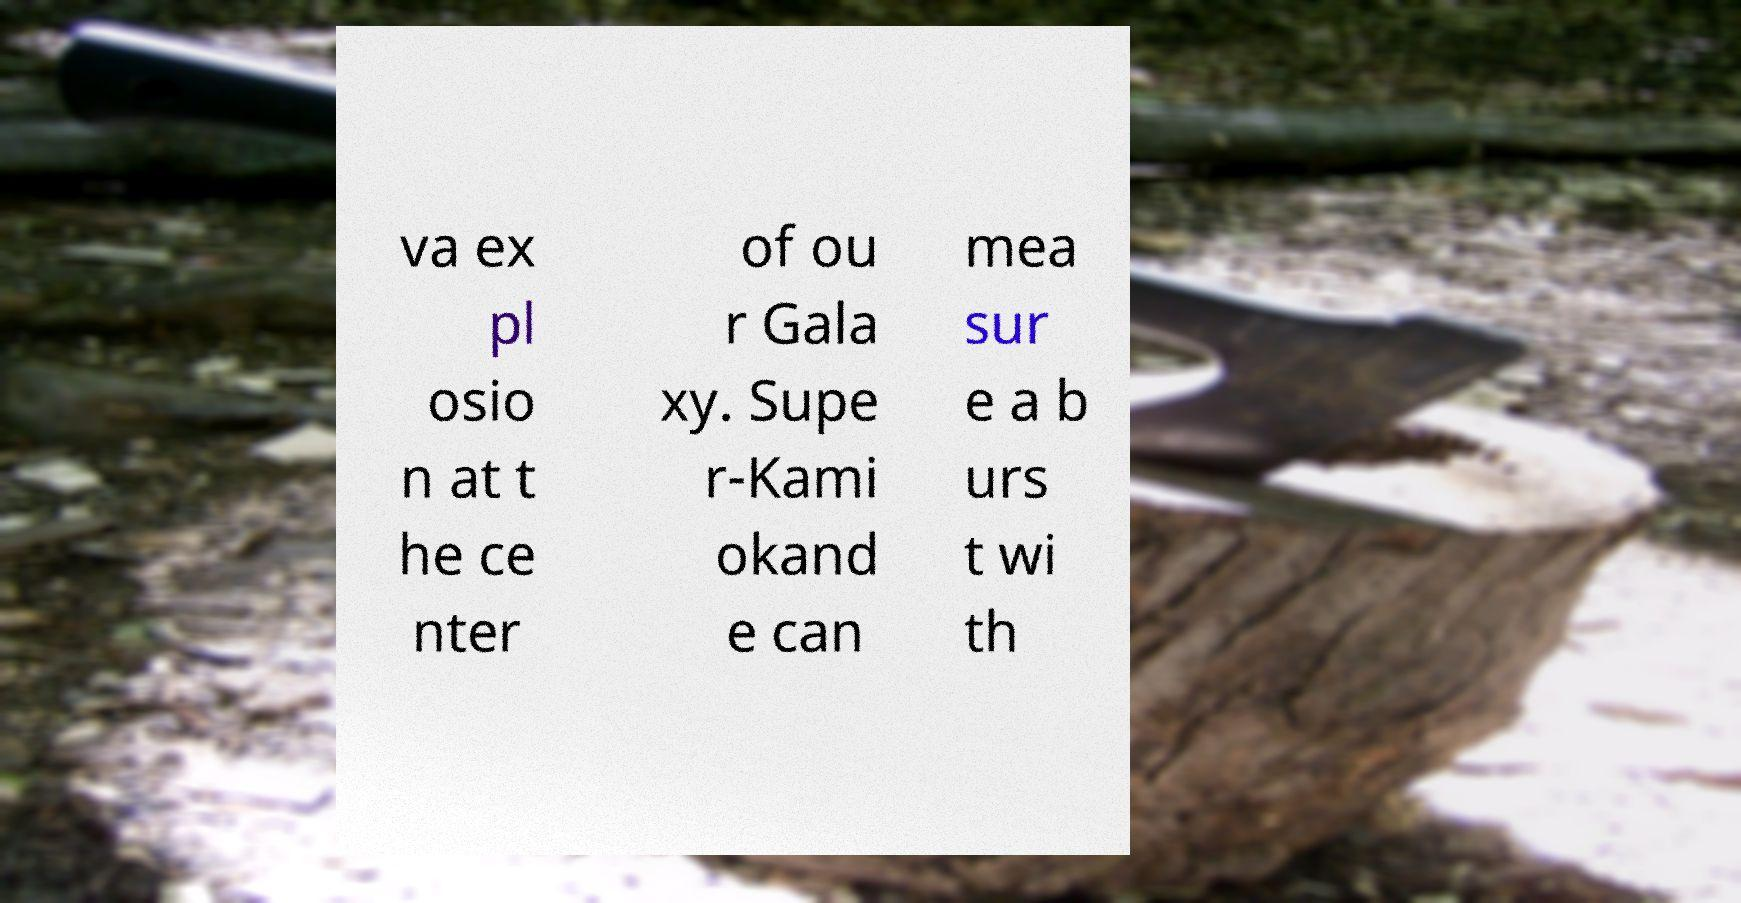There's text embedded in this image that I need extracted. Can you transcribe it verbatim? va ex pl osio n at t he ce nter of ou r Gala xy. Supe r-Kami okand e can mea sur e a b urs t wi th 